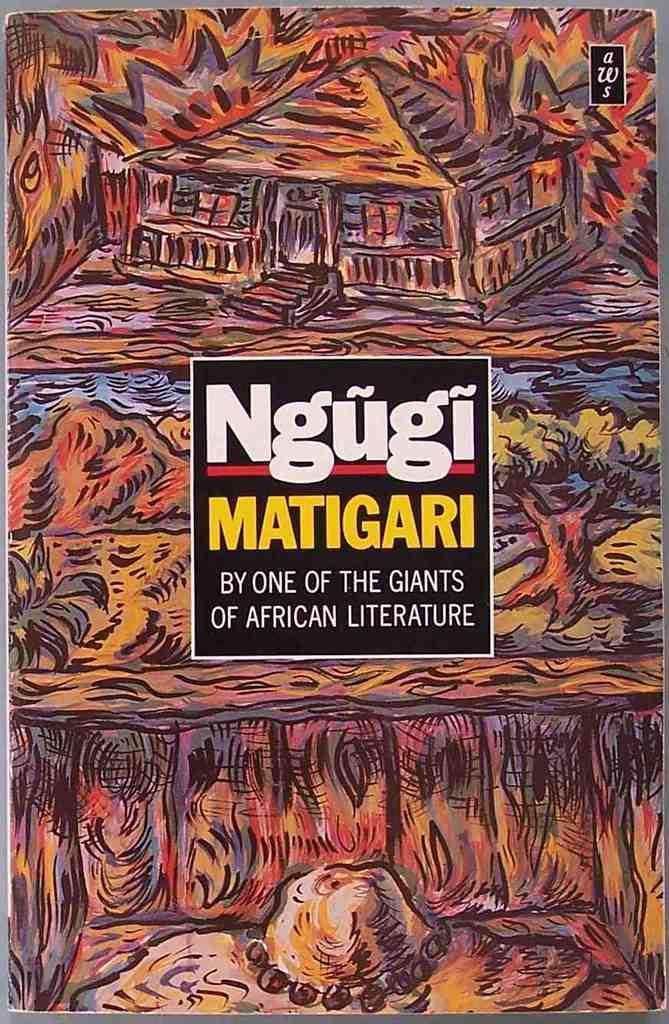What is the name of this book?
Give a very brief answer. Ngugi matigari. 